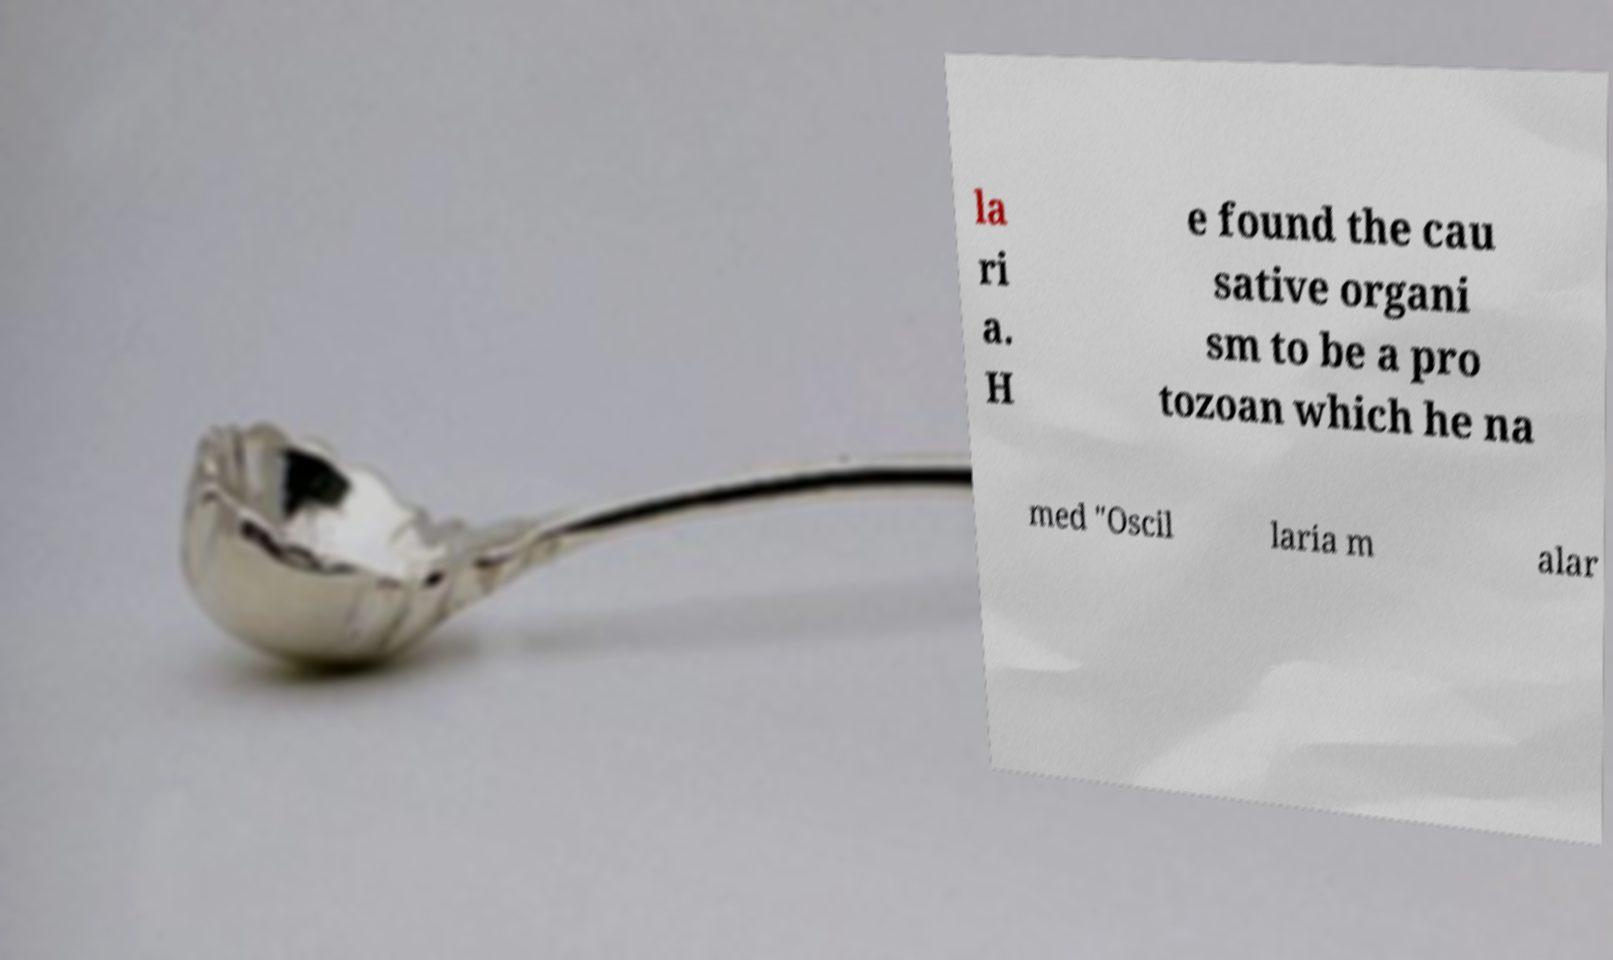Can you read and provide the text displayed in the image?This photo seems to have some interesting text. Can you extract and type it out for me? la ri a. H e found the cau sative organi sm to be a pro tozoan which he na med "Oscil laria m alar 